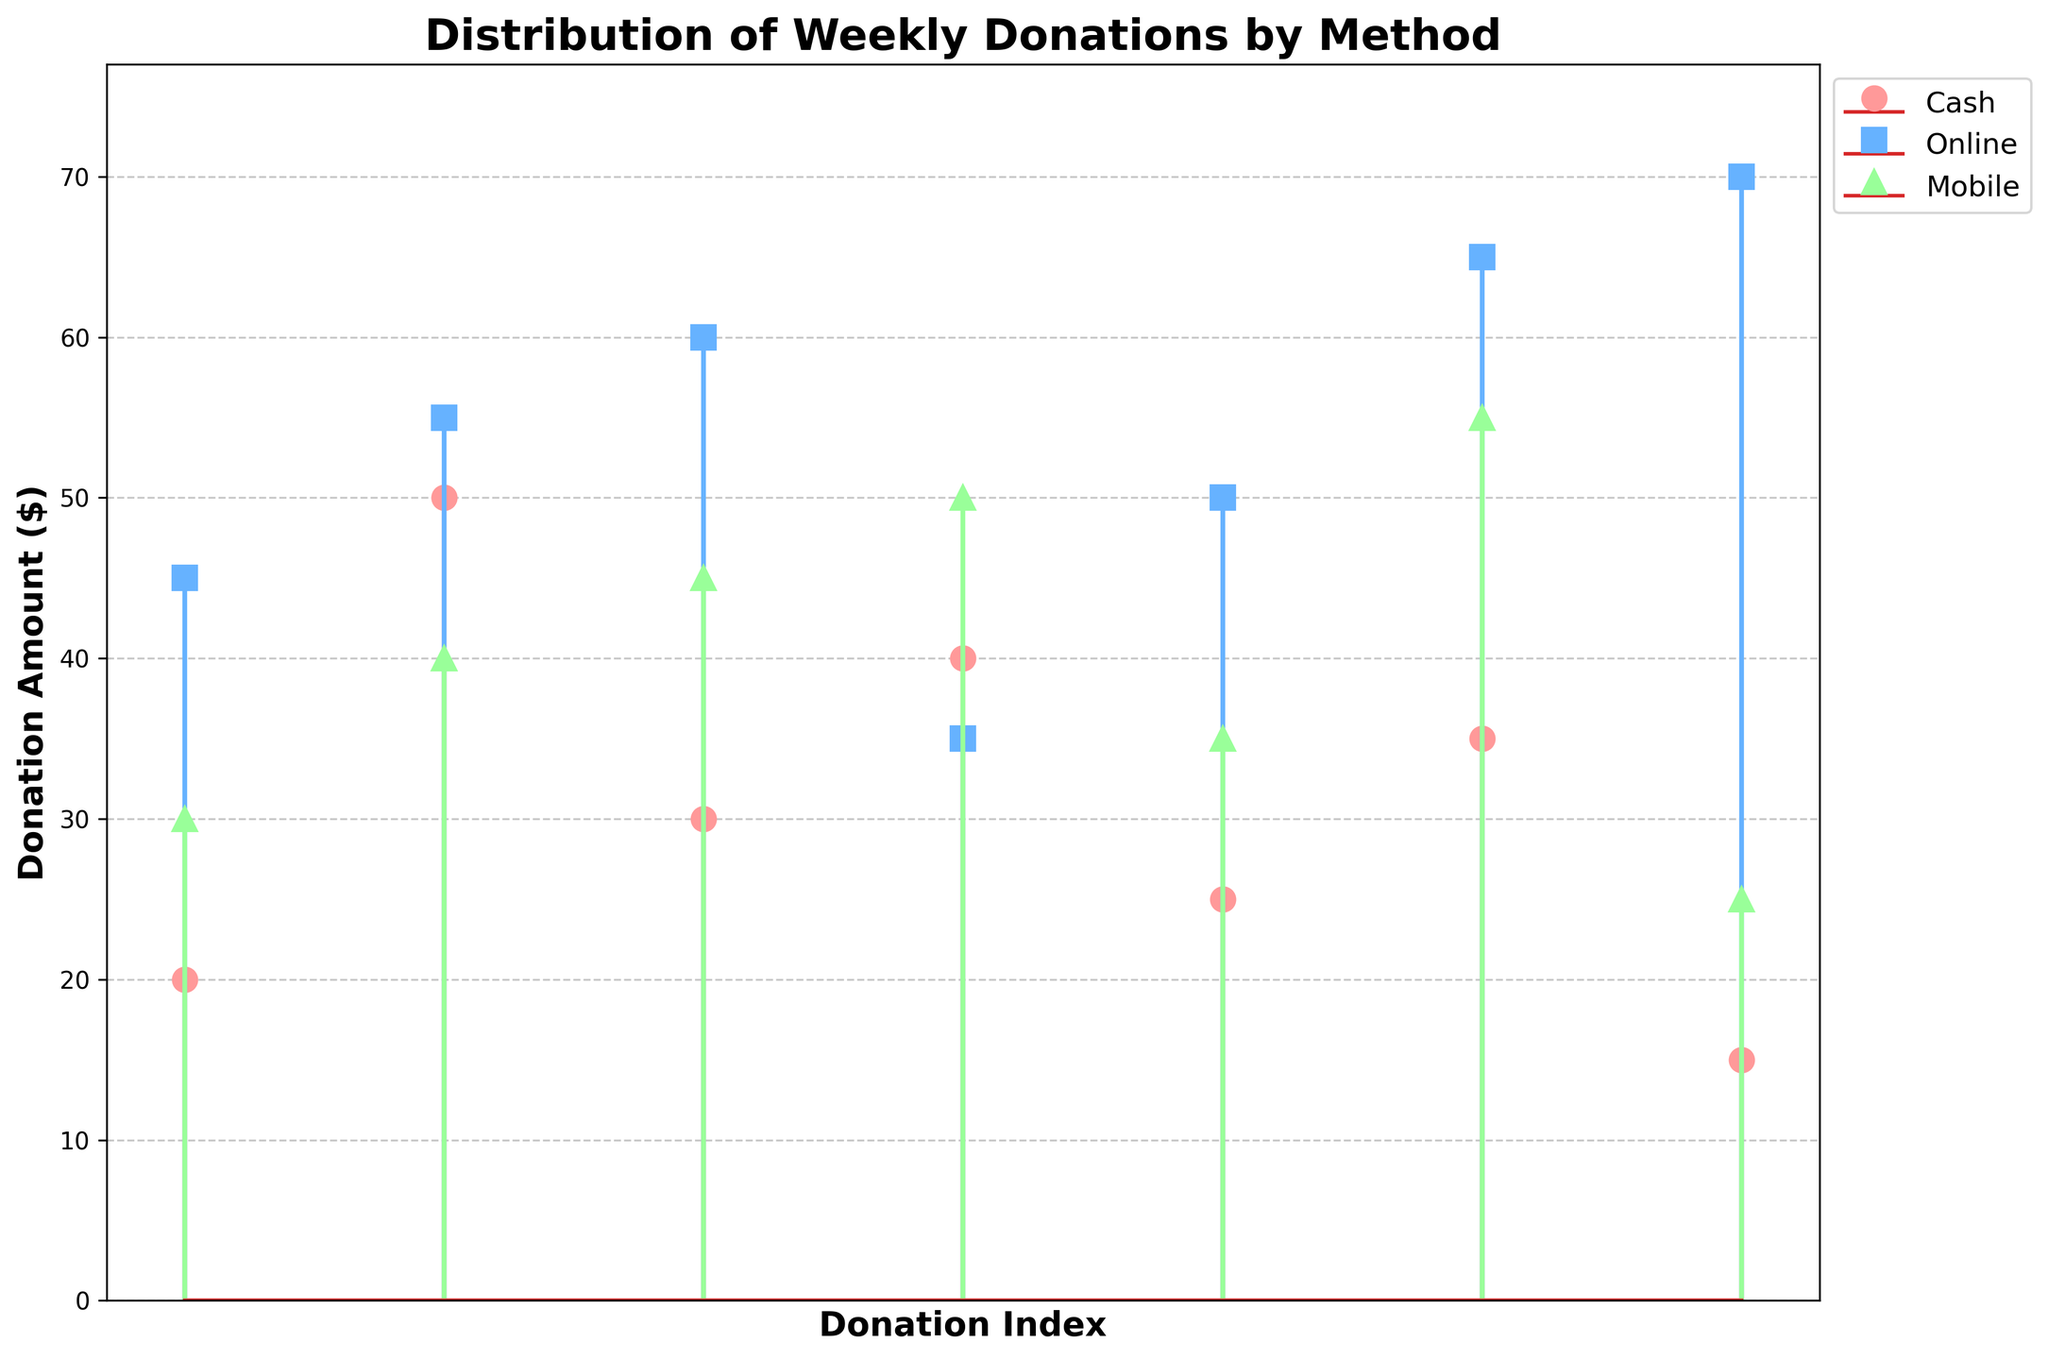What is the title of the plot? The title is the text at the top of the plot. It states what the plot is about, summarizing the information in a concise way. Here, the title is "Distribution of Weekly Donations by Method".
Answer: Distribution of Weekly Donations by Method What are the labels for the X and Y axes? Axes labels are text labels on the horizontal and vertical sides of the plot, respectively. The X-axis label is "Donation Index", and the Y-axis label is "Donation Amount ($)".
Answer: Donation Index, Donation Amount ($) How many different donation methods are represented in the plot? The donation methods are represented by different colored lines and markers in the legend. By checking the legend, we see there are three methods: "Cash", "Online", and "Mobile".
Answer: 3 What is the highest donation amount for the Mobile method? By looking at the stem plot for the Mobile method, which uses triangles and green lines, the highest stem reaches 55.
Answer: 55 What is the median donation amount for the Online method? To find the median, we list all the donation amounts for Online: 35, 45, 50, 55, 60, 65, 70. The middle value in this sorted list is the fourth value, 55.
Answer: 55 Which donation method has the smallest range of donation amounts? The range is the difference between the smallest and largest value. For Cash, the range is 50 - 15 = 35. For Online, it's 70 - 35 = 35. For Mobile, it's 55 - 25 = 30. Mobile has the smallest range.
Answer: Mobile What is the total number of cash donations represented in the plot? By counting the number of markers for the Cash method in the plot, we see there are 7 cash donations.
Answer: 7 Which donation method has the highest minimum donation amount? The minimum donation amounts are the smallest stems. For Cash, it's 15. For Online, it's 35. For Mobile, it's 25. Online has the highest minimum donation.
Answer: Online On average, are donations higher for the Online method compared to the Cash method? First, find the average for each:
Cash: (20+50+30+40+25+35+15)/7 = 215/7 ≈ 30.71
Online: (45+55+60+35+50+65+70)/7 = 380/7 ≈ 54.29
Yes, on average, Online donations are higher than Cash donations.
Answer: Yes How many donation methods include donations that are above 50? For Cash, counting markers above 50: 1. For Online: 5. For Mobile: 2. Therefore, two methods have donations above 50.
Answer: 2 